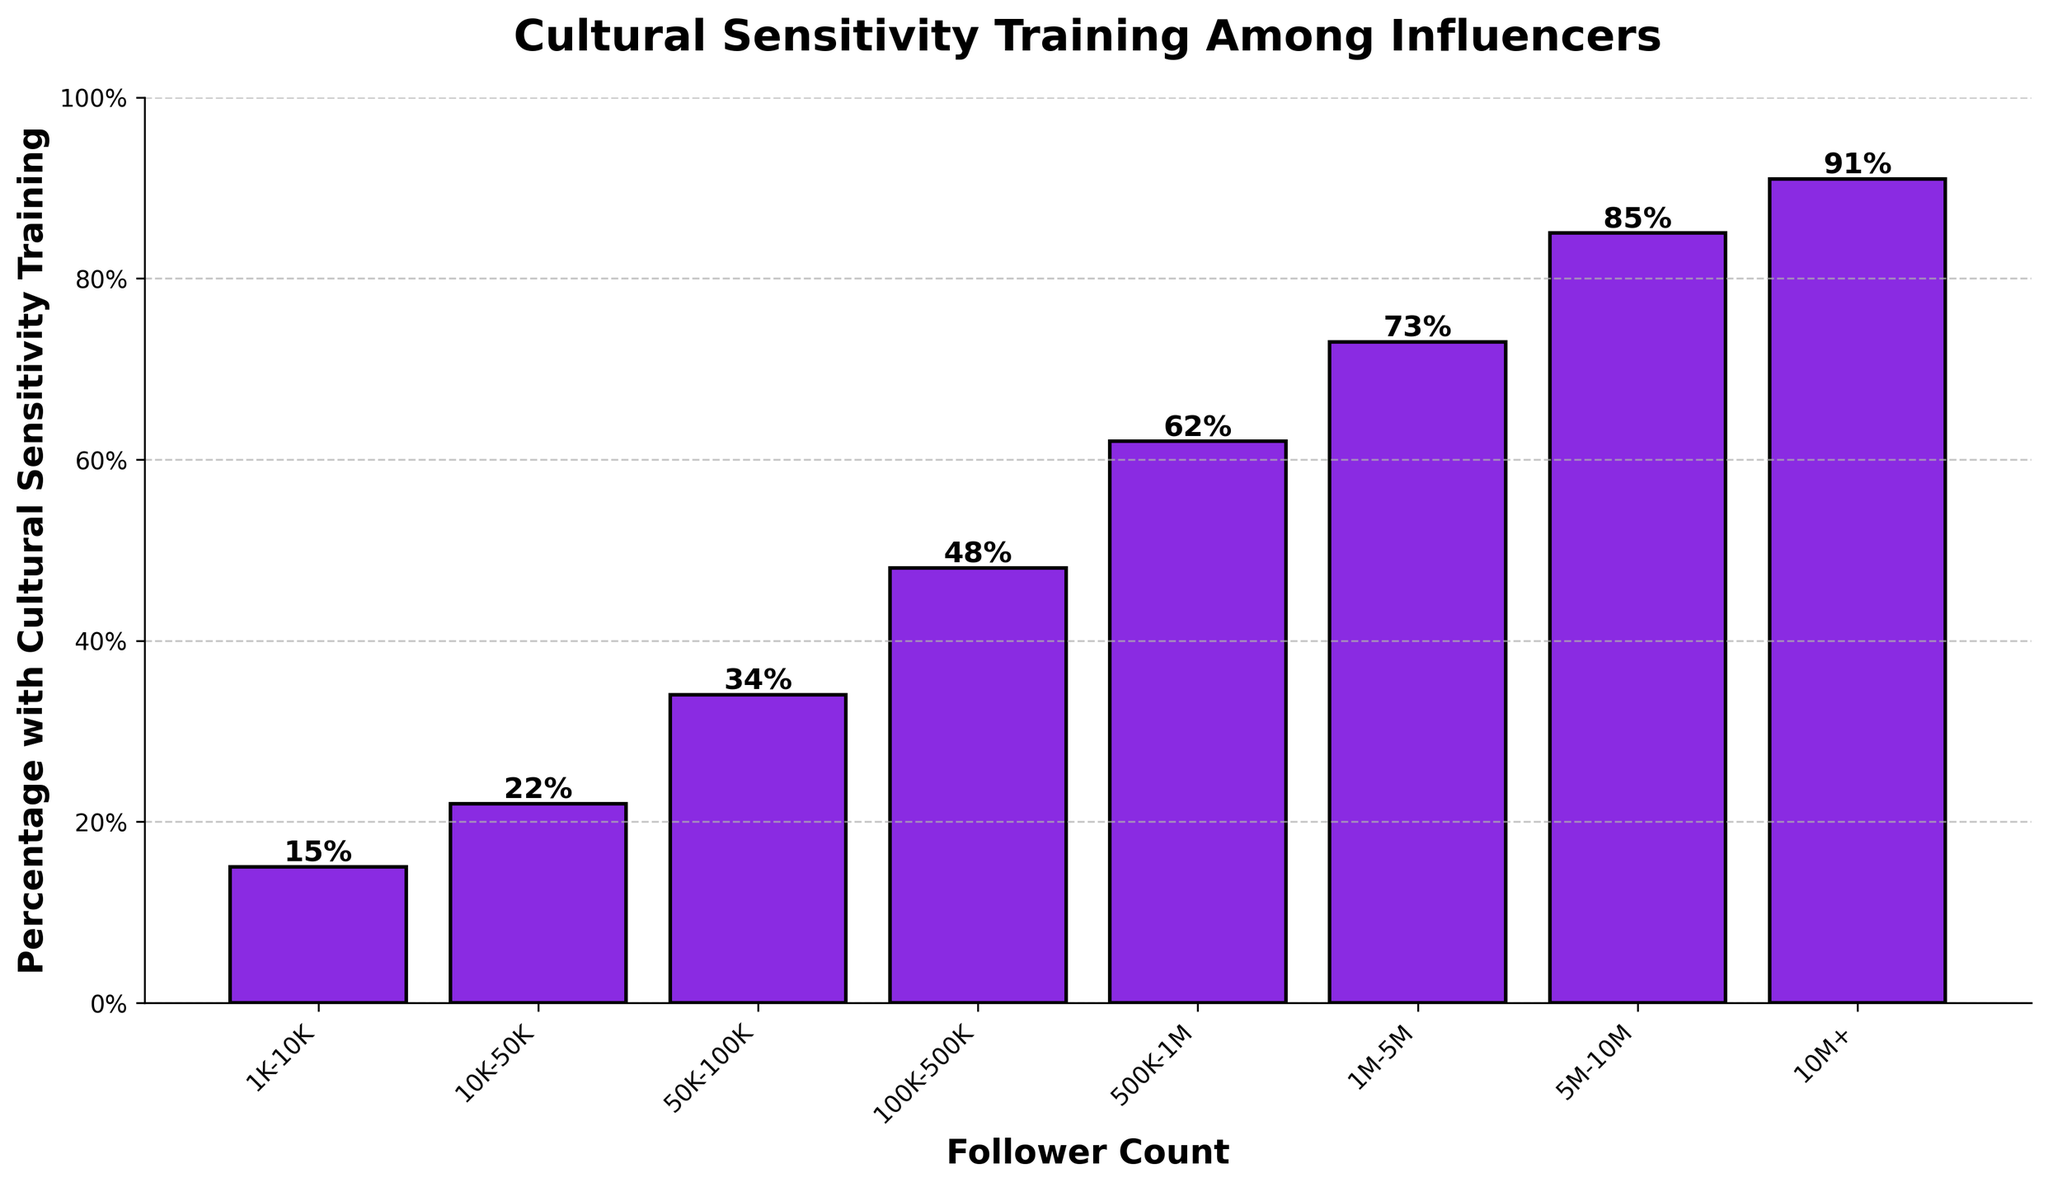What is the percentage of influencers with 500K-1M followers who have undergone cultural sensitivity training? Look at the bar corresponding to the follower count range "500K-1M". The bar is labeled with the percentage.
Answer: 62% Which follower count range has the highest percentage of influencers with cultural sensitivity training? Among the bars in the chart, identify the tallest one. The follower count range above it is "10M+".
Answer: 10M+ Compare the percentage of influencers with 50K-100K followers to those with 1M-5M followers. Which is higher and by how much? Locate the bars for "50K-100K" and "1M-5M". The percentage for "50K-100K" is 34% and for "1M-5M" is 73%. Subtract to find the difference: 73% − 34% = 39%.
Answer: 1M-5M is higher by 39% What is the percentage increase in cultural sensitivity training from influencers with 1K-10K followers to those with 100K-500K followers? Find the percentage for "1K-10K" (15%) and "100K-500K" (48%). Subtract the smaller percentage from the larger one, then divide by the smaller percentage and multiply by 100: ((48 - 15) / 15) * 100 = 220%.
Answer: 220% How do the percentages of influencers with 10K-50K followers and 5M-10M followers compare visually? Observe the heights of the bars at "10K-50K" (22%) and "5M-10M" (85%). The bar for "5M-10M" is much taller, indicating a higher percentage.
Answer: 5M-10M has a much higher percentage Considering the follower ranges "100K-500K" and "500K-1M", what is their average percentage with cultural sensitivity training? Find the percentages: 48% for "100K-500K" and 62% for "500K-1M". Calculate their average: (48 + 62) / 2 = 55%.
Answer: 55% Which follower count range has the median percentage of cultural sensitivity training? List all percentages: 15%, 22%, 34%, 48%, 62%, 73%, 85%, 91%. The median is the middle value in the sorted list. For an even number of values, the median is the average of the 4th and 5th values: (48 + 62) / 2 = 55%.
Answer: 100K-500K and 500K-1M What is the visual difference in bar height between the 1K-10K range and the 10M+ range? Notice that the bar for "10M+" (91%) is almost six times taller than that for "1K-10K" (15%).
Answer: "10M+" is much taller If I combine the follower ranges "500K-1M" and "1M-5M", what is their combined percentage of cultural sensitivity training? Add the percentages: 62% (500K-1M) + 73% (1M-5M) = 135%.
Answer: 135% What is the smallest percentage of influencers who have undergone cultural sensitivity training, and to which follower count range does it belong? Locate the shortest bar, which is for "1K-10K". The percentage is 15%.
Answer: 15%, 1K-10K 